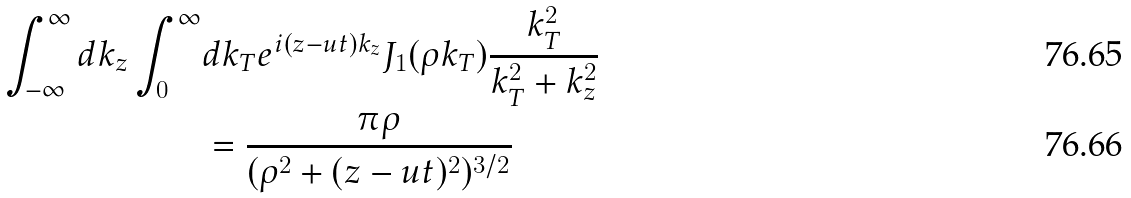Convert formula to latex. <formula><loc_0><loc_0><loc_500><loc_500>\int _ { - \infty } ^ { \infty } d k _ { z } \int _ { 0 } ^ { \infty } & d k _ { T } e ^ { i ( z - u t ) k _ { z } } J _ { 1 } ( \rho k _ { T } ) \frac { k _ { T } ^ { 2 } } { k _ { T } ^ { 2 } + k _ { z } ^ { 2 } } \\ & = \frac { \pi \rho } { ( \rho ^ { 2 } + ( z - u t ) ^ { 2 } ) ^ { 3 / 2 } }</formula> 